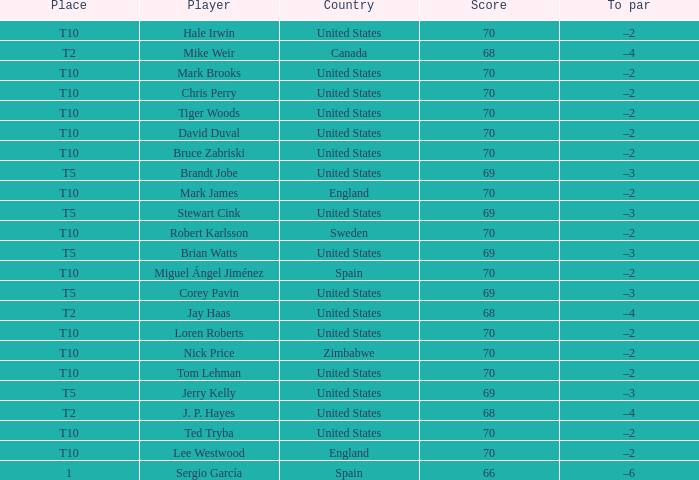What was the To par of the golfer that placed t5? –3, –3, –3, –3, –3. 